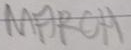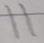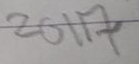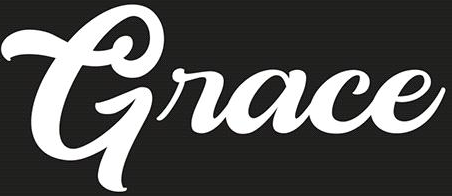Read the text content from these images in order, separated by a semicolon. MARCH; 11; 2017; Grace 